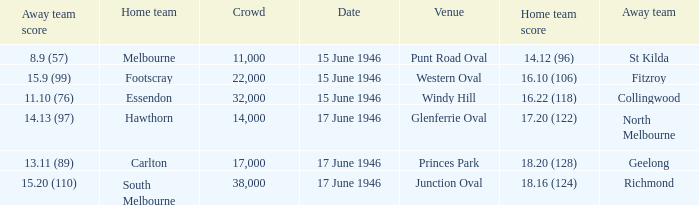Can you give me this table as a dict? {'header': ['Away team score', 'Home team', 'Crowd', 'Date', 'Venue', 'Home team score', 'Away team'], 'rows': [['8.9 (57)', 'Melbourne', '11,000', '15 June 1946', 'Punt Road Oval', '14.12 (96)', 'St Kilda'], ['15.9 (99)', 'Footscray', '22,000', '15 June 1946', 'Western Oval', '16.10 (106)', 'Fitzroy'], ['11.10 (76)', 'Essendon', '32,000', '15 June 1946', 'Windy Hill', '16.22 (118)', 'Collingwood'], ['14.13 (97)', 'Hawthorn', '14,000', '17 June 1946', 'Glenferrie Oval', '17.20 (122)', 'North Melbourne'], ['13.11 (89)', 'Carlton', '17,000', '17 June 1946', 'Princes Park', '18.20 (128)', 'Geelong'], ['15.20 (110)', 'South Melbourne', '38,000', '17 June 1946', 'Junction Oval', '18.16 (124)', 'Richmond']]} On what date did a home team score 16.10 (106)? 15 June 1946. 